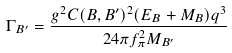Convert formula to latex. <formula><loc_0><loc_0><loc_500><loc_500>\Gamma _ { B ^ { \prime } } = \frac { g ^ { 2 } C ( B , B ^ { \prime } ) ^ { 2 } ( E _ { B } + M _ { B } ) { q } ^ { 3 } } { 2 4 \pi f _ { \pi } ^ { 2 } M _ { B ^ { \prime } } }</formula> 